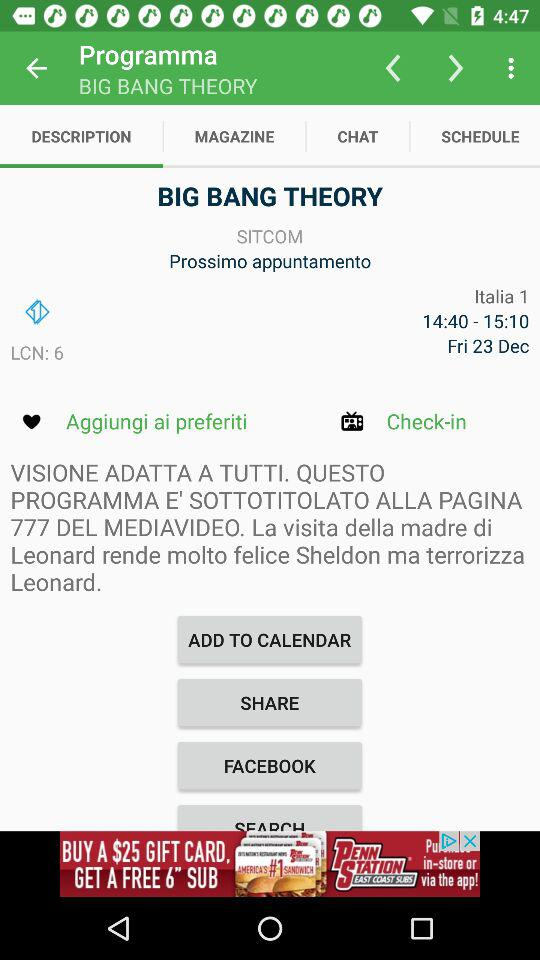What is the name of the theory? The name of the theory is "BIG BANG THEORY". 